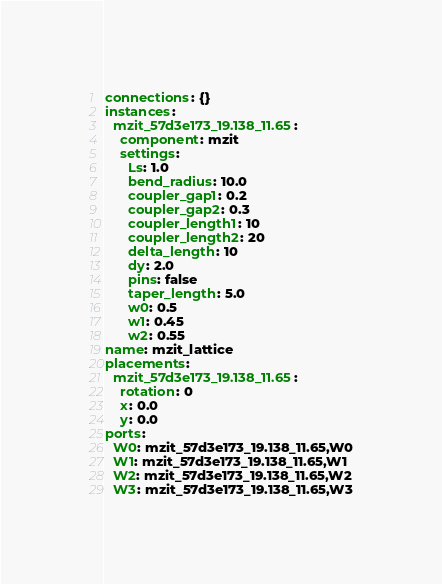Convert code to text. <code><loc_0><loc_0><loc_500><loc_500><_YAML_>connections: {}
instances:
  mzit_57d3e173_19.138_11.65:
    component: mzit
    settings:
      Ls: 1.0
      bend_radius: 10.0
      coupler_gap1: 0.2
      coupler_gap2: 0.3
      coupler_length1: 10
      coupler_length2: 20
      delta_length: 10
      dy: 2.0
      pins: false
      taper_length: 5.0
      w0: 0.5
      w1: 0.45
      w2: 0.55
name: mzit_lattice
placements:
  mzit_57d3e173_19.138_11.65:
    rotation: 0
    x: 0.0
    y: 0.0
ports:
  W0: mzit_57d3e173_19.138_11.65,W0
  W1: mzit_57d3e173_19.138_11.65,W1
  W2: mzit_57d3e173_19.138_11.65,W2
  W3: mzit_57d3e173_19.138_11.65,W3
</code> 